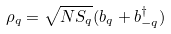<formula> <loc_0><loc_0><loc_500><loc_500>\rho _ { q } = \sqrt { N S _ { q } } ( b _ { q } + b ^ { \dagger } _ { - { q } } )</formula> 